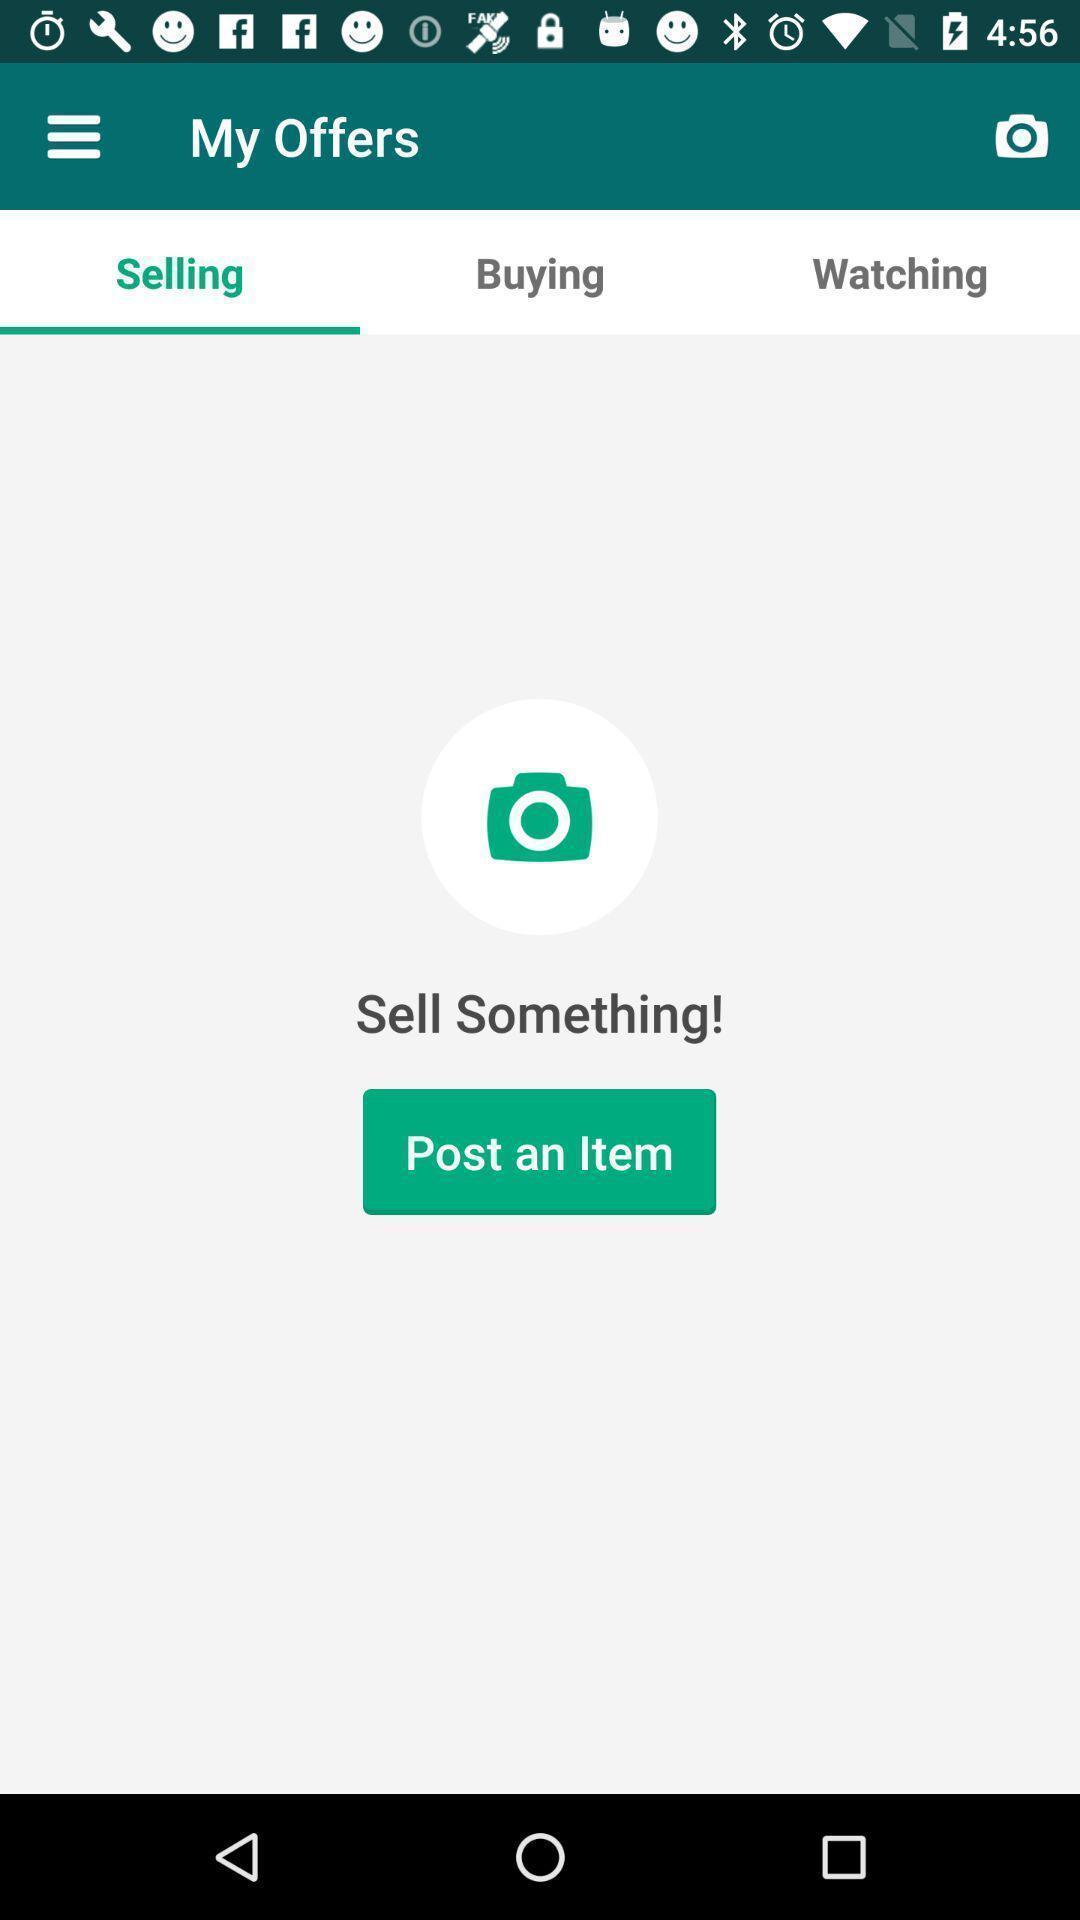What can you discern from this picture? Page showing option like post an item. 